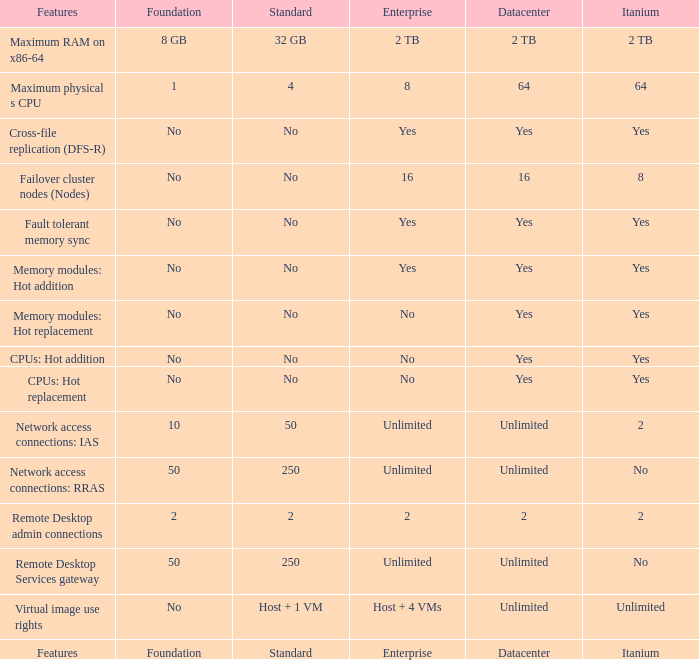What is the Datacenter for the Memory modules: hot addition Feature that has Yes listed for Itanium? Yes. 